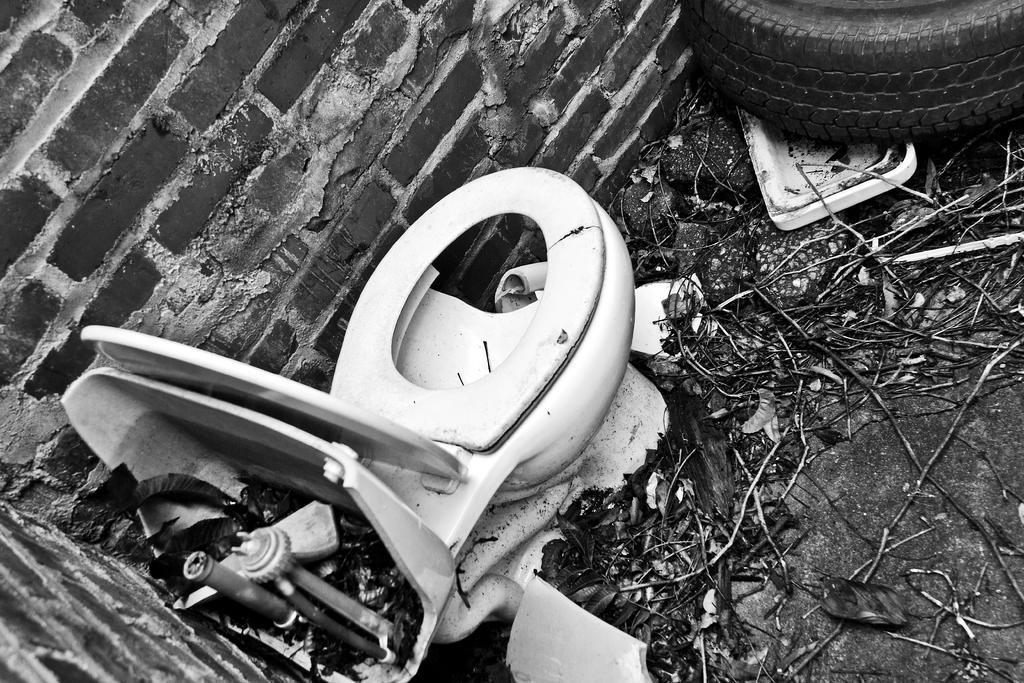Can you describe this image briefly? In this image I can see the black and white picture in which I can see a toilet seat, a tyre, few sticks and leaves on the ground and the wall which is made up of bricks. 